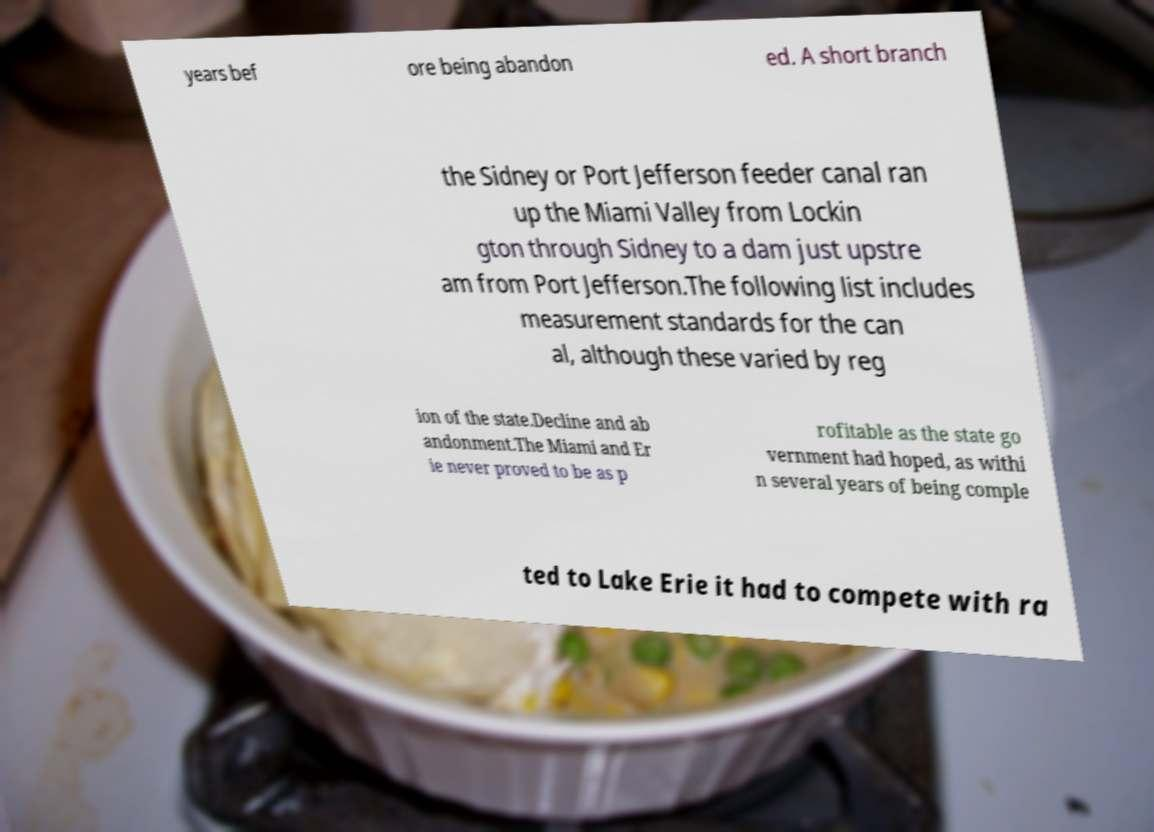I need the written content from this picture converted into text. Can you do that? years bef ore being abandon ed. A short branch the Sidney or Port Jefferson feeder canal ran up the Miami Valley from Lockin gton through Sidney to a dam just upstre am from Port Jefferson.The following list includes measurement standards for the can al, although these varied by reg ion of the state.Decline and ab andonment.The Miami and Er ie never proved to be as p rofitable as the state go vernment had hoped, as withi n several years of being comple ted to Lake Erie it had to compete with ra 